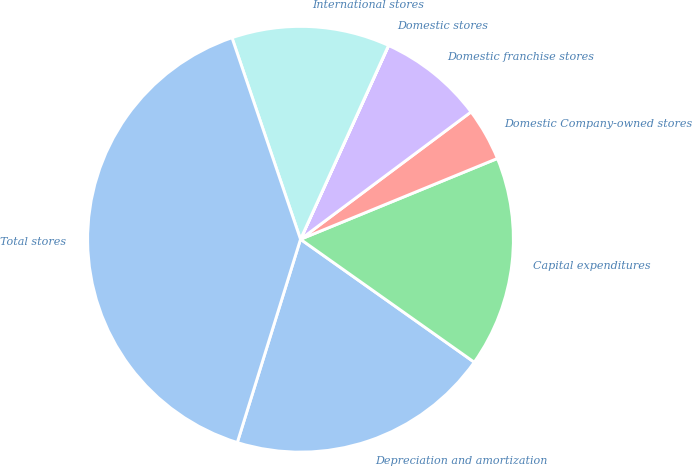Convert chart to OTSL. <chart><loc_0><loc_0><loc_500><loc_500><pie_chart><fcel>Depreciation and amortization<fcel>Capital expenditures<fcel>Domestic Company-owned stores<fcel>Domestic franchise stores<fcel>Domestic stores<fcel>International stores<fcel>Total stores<nl><fcel>20.0%<fcel>16.0%<fcel>4.01%<fcel>8.0%<fcel>0.01%<fcel>12.0%<fcel>39.99%<nl></chart> 